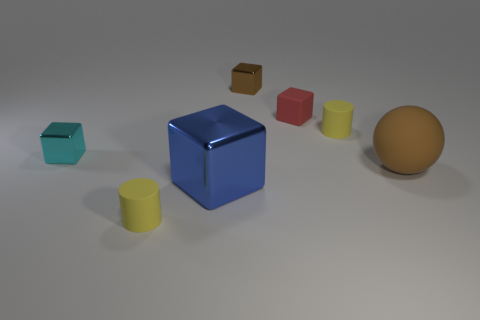Subtract all yellow cylinders. How many were subtracted if there are1yellow cylinders left? 1 Subtract all small cyan shiny cubes. How many cubes are left? 3 Subtract all brown cubes. How many cubes are left? 3 Subtract all balls. How many objects are left? 6 Subtract 1 spheres. How many spheres are left? 0 Subtract all blue blocks. How many yellow spheres are left? 0 Add 2 yellow cylinders. How many objects exist? 9 Add 2 tiny cyan shiny blocks. How many tiny cyan shiny blocks are left? 3 Add 7 large cyan metallic things. How many large cyan metallic things exist? 7 Subtract 0 gray blocks. How many objects are left? 7 